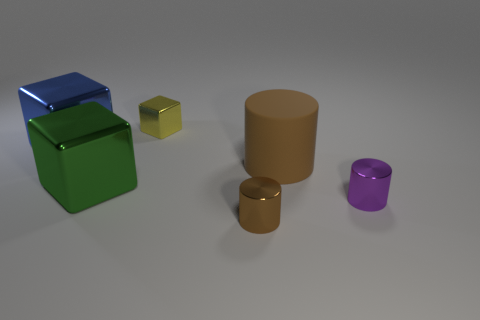Add 1 green blocks. How many objects exist? 7 Subtract 1 yellow blocks. How many objects are left? 5 Subtract all large purple cylinders. Subtract all yellow metal things. How many objects are left? 5 Add 1 green metal objects. How many green metal objects are left? 2 Add 1 tiny brown metal objects. How many tiny brown metal objects exist? 2 